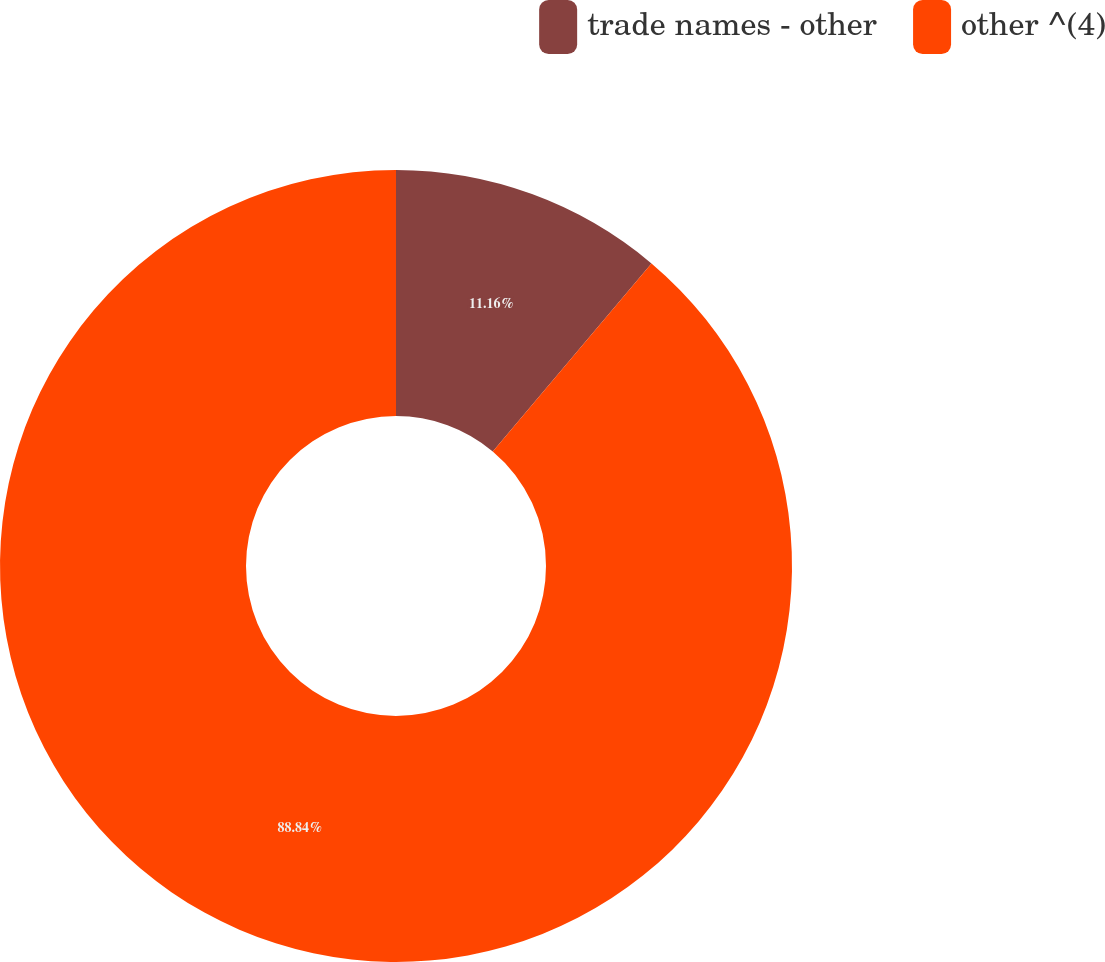<chart> <loc_0><loc_0><loc_500><loc_500><pie_chart><fcel>trade names - other<fcel>other ^(4)<nl><fcel>11.16%<fcel>88.84%<nl></chart> 